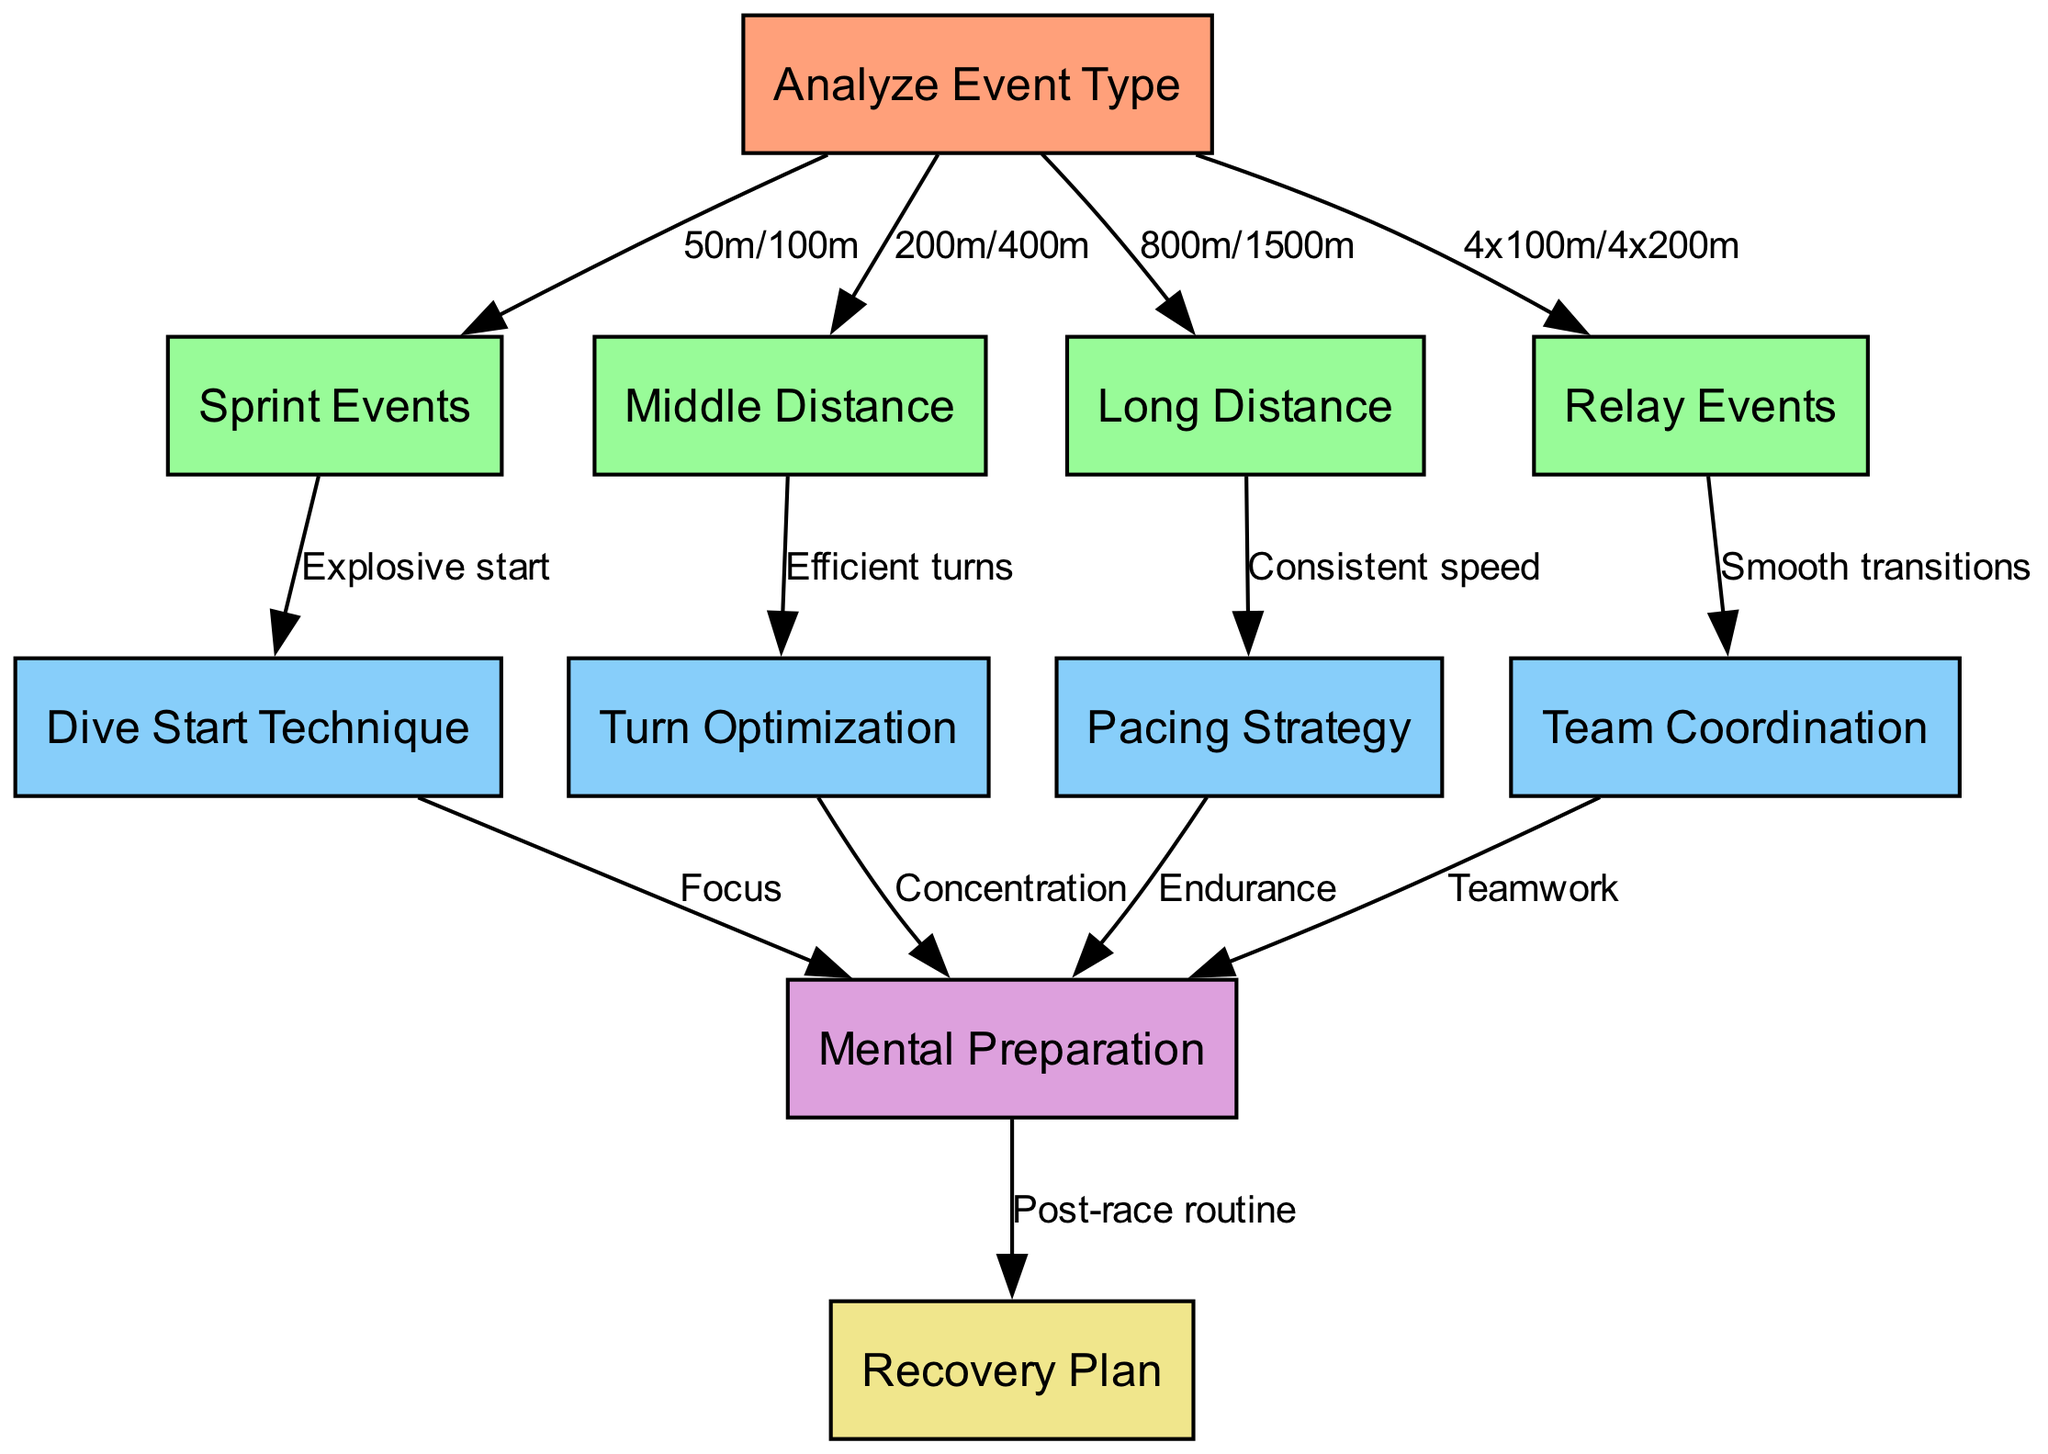What is the starting node of the diagram? The starting node is explicitly labeled in the diagram as "Analyze Event Type." This is the node where the entire flow begins.
Answer: Analyze Event Type How many nodes are there in total? By counting the nodes listed in the data, including the start node and all event types, there are 10 nodes: 1 start node + 9 event-related nodes.
Answer: 10 What type of event does "Dive Start Technique" originate from? Following the arrows in the diagram, "Dive Start Technique" comes from "Sprint Events," indicating that it is a strategy specifically for sprint events.
Answer: Sprint Events Which nodes connect to "Mental Preparation"? The diagram shows that "Mental Preparation" is connected by four nodes: "Dive Start Technique," "Turn Optimization," "Pacing Strategy," and "Team Coordination." Each contributes to the mental aspect of preparation.
Answer: Dive Start Technique, Turn Optimization, Pacing Strategy, Team Coordination What is the final node in the flow? The diagram indicates that "Recovery Plan" is the last node reached after "Mental Preparation," signifying that recovery is the last step in the strategy.
Answer: Recovery Plan How many edges connect to the "Middle Distance" node? The diagram shows one edge originating from "Middle Distance," which leads to "Turn Optimization," meaning there's only one path emanating from this node.
Answer: 1 Which node is related to "Smooth transitions"? "Smooth transitions" is labeled on the edge leading from "Relay Events," indicating it is an important aspect of relay preparation.
Answer: Relay Events What does the edge from "Team Coordination" to "Mental Preparation" signify? This edge labeled "Teamwork" signifies that effective team coordination contributes positively to the mental preparation of the swimmers.
Answer: Teamwork What event types are included under "Sprint Events"? The term "Sprint Events" in the diagram encompasses the specific events of "50m" and "100m," showing the distance categories for sprinting.
Answer: 50m/100m 